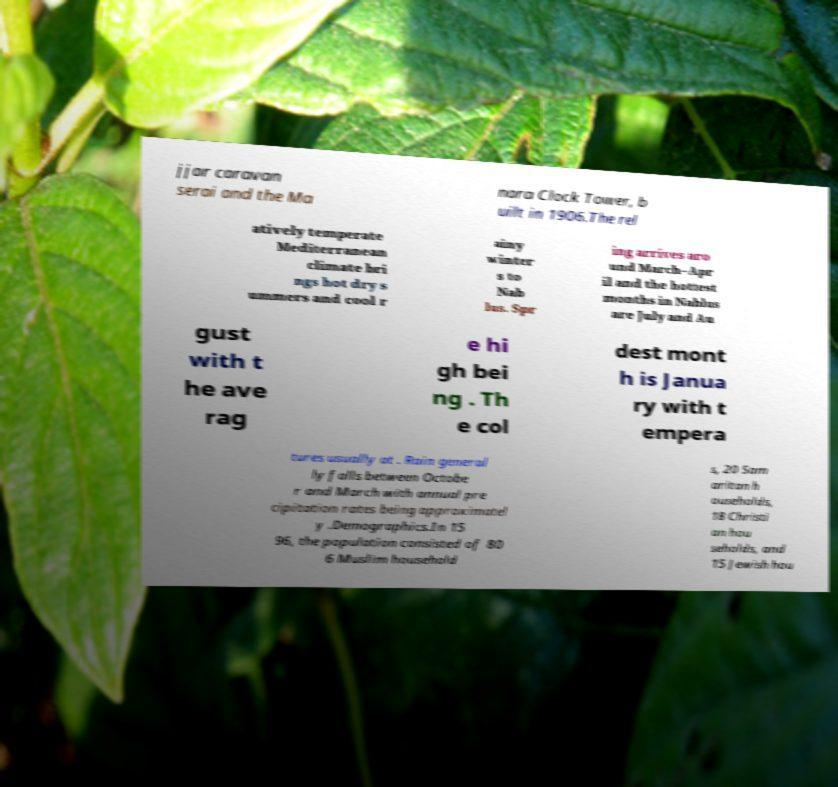Please identify and transcribe the text found in this image. jjar caravan serai and the Ma nara Clock Tower, b uilt in 1906.The rel atively temperate Mediterranean climate bri ngs hot dry s ummers and cool r ainy winter s to Nab lus. Spr ing arrives aro und March–Apr il and the hottest months in Nablus are July and Au gust with t he ave rag e hi gh bei ng . Th e col dest mont h is Janua ry with t empera tures usually at . Rain general ly falls between Octobe r and March with annual pre cipitation rates being approximatel y .Demographics.In 15 96, the population consisted of 80 6 Muslim household s, 20 Sam aritan h ouseholds, 18 Christi an hou seholds, and 15 Jewish hou 